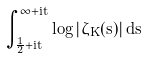Convert formula to latex. <formula><loc_0><loc_0><loc_500><loc_500>\int _ { \frac { 1 } { 2 } + i t } ^ { \infty + i t } \log | \zeta _ { K } ( s ) | \, d s</formula> 